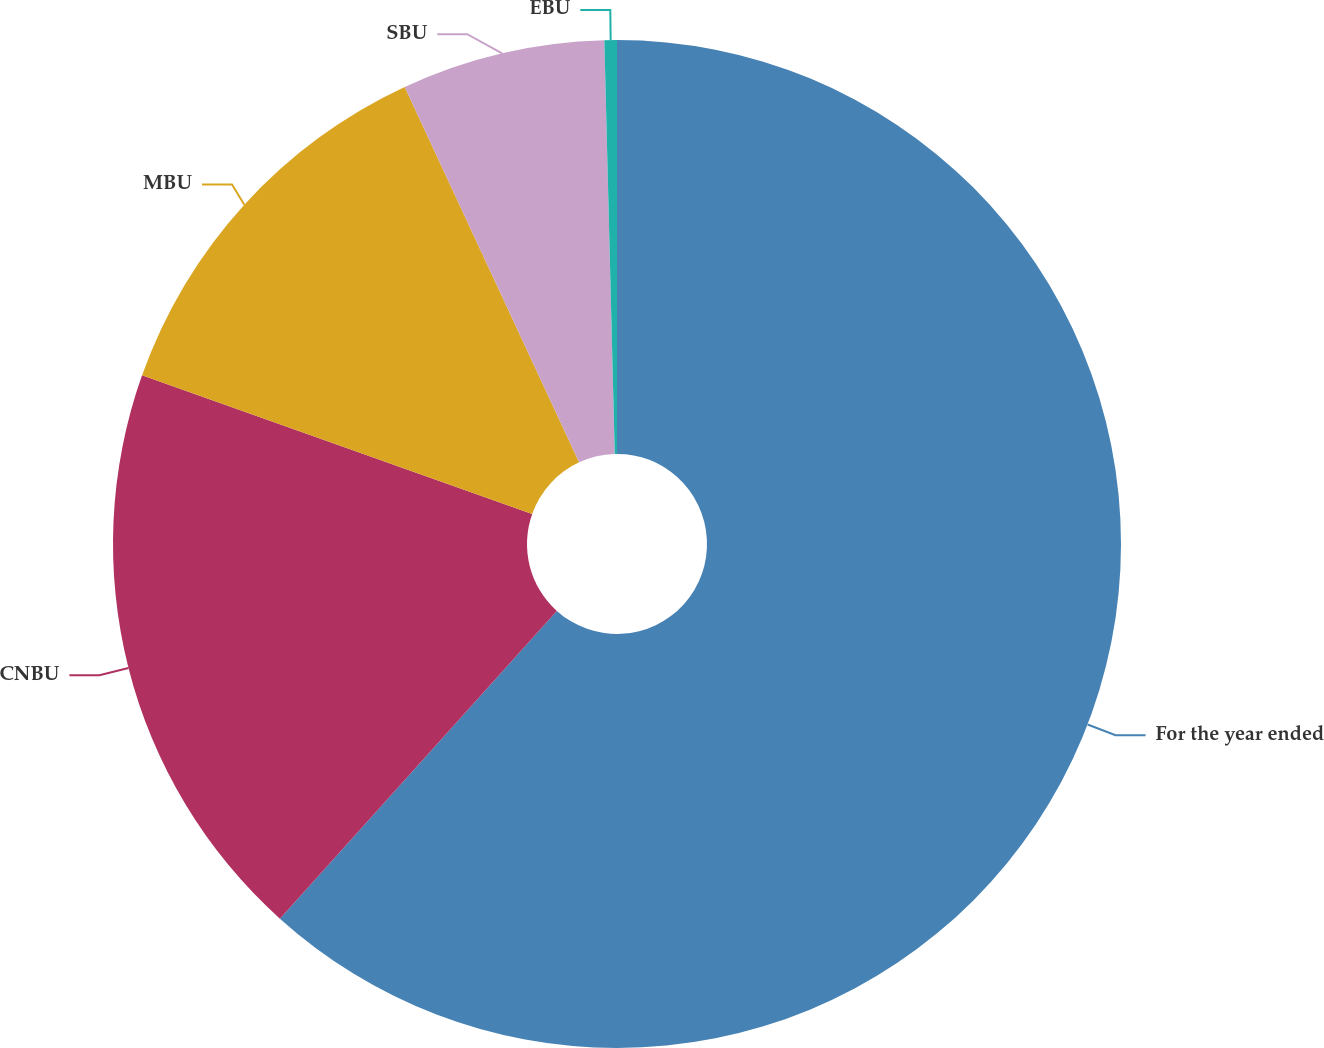Convert chart. <chart><loc_0><loc_0><loc_500><loc_500><pie_chart><fcel>For the year ended<fcel>CNBU<fcel>MBU<fcel>SBU<fcel>EBU<nl><fcel>61.66%<fcel>18.77%<fcel>12.65%<fcel>6.52%<fcel>0.4%<nl></chart> 